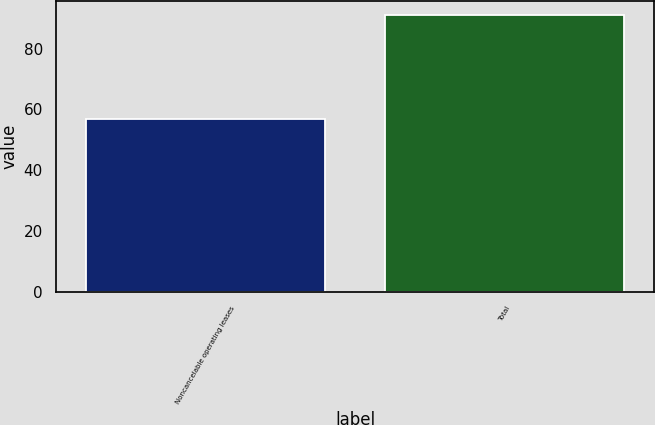Convert chart. <chart><loc_0><loc_0><loc_500><loc_500><bar_chart><fcel>Noncancelable operating leases<fcel>Total<nl><fcel>57<fcel>91<nl></chart> 